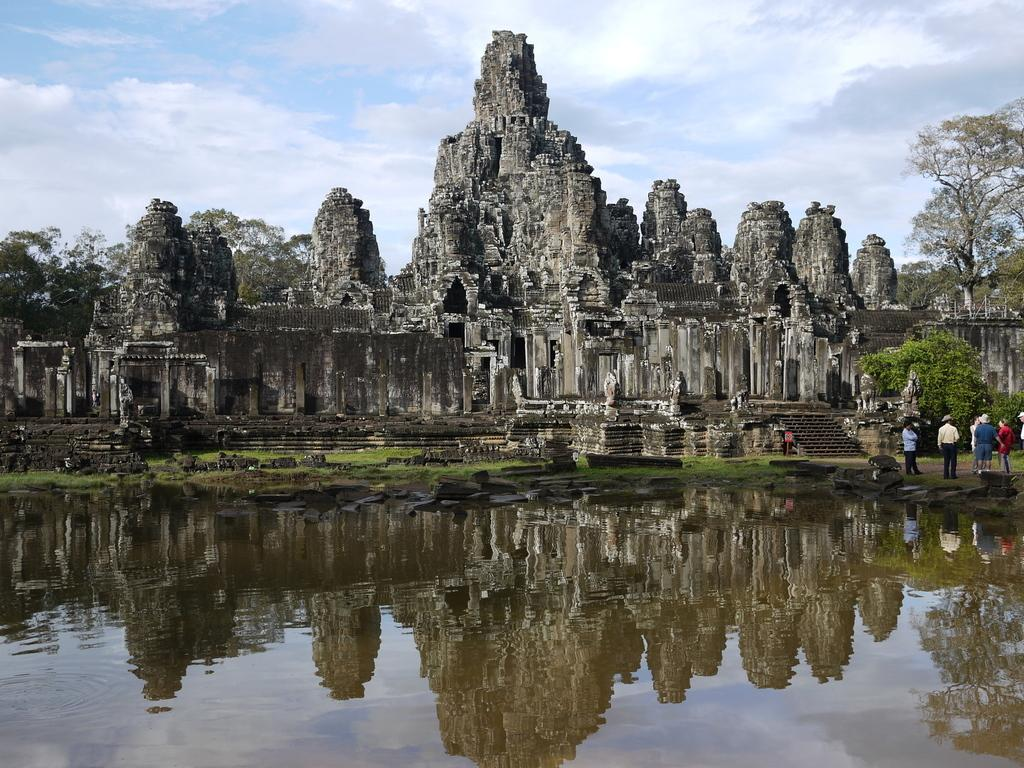What is the primary element present in the image? There is water in the image. What are the people in the image doing? The people are standing on the ground in the image. What architectural feature can be seen in the image? There are stairs visible in the image. What type of natural vegetation is present in the image? There are trees in the image. What type of historical or cultural structure is visible in the image? There is an ancient architecture in the image. What is the rate at which the umbrella is spinning in the image? There is no umbrella present in the image, so it is not possible to determine its rate of spinning. 